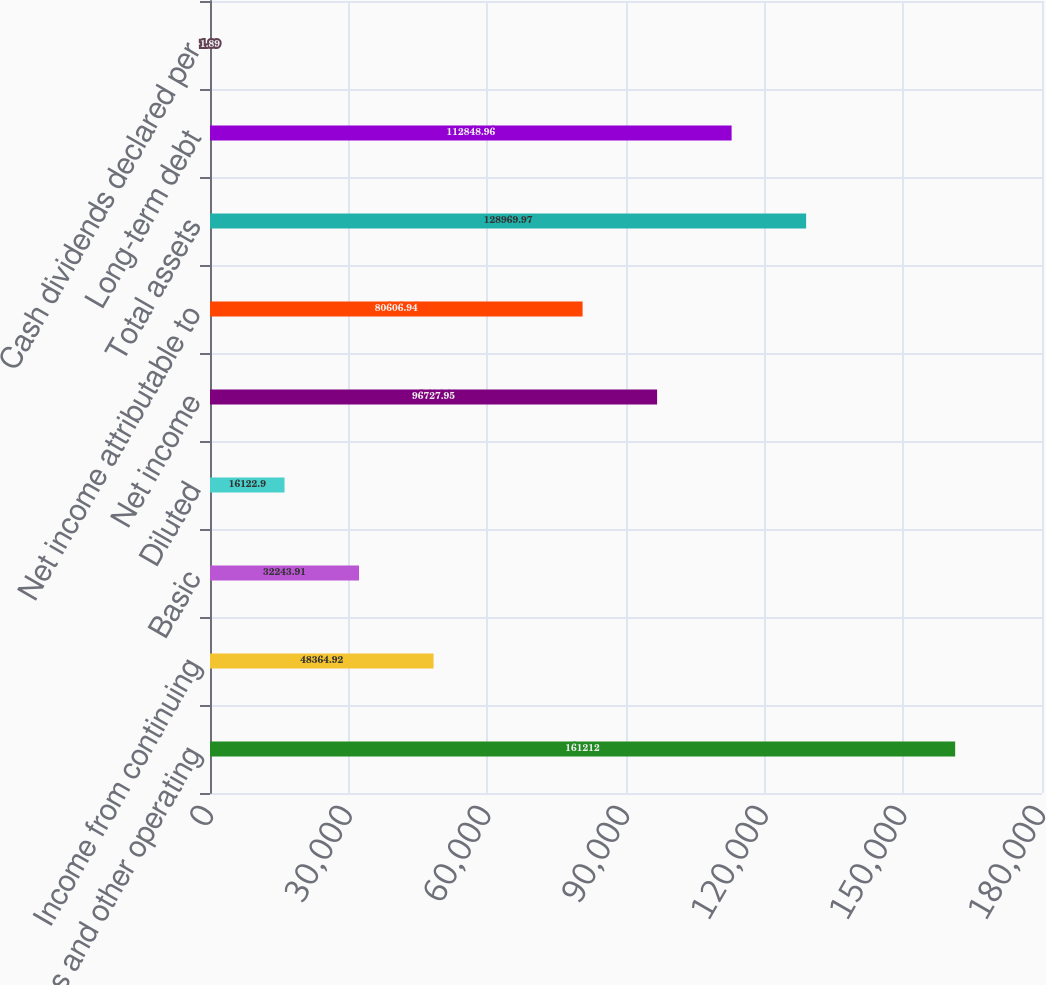Convert chart to OTSL. <chart><loc_0><loc_0><loc_500><loc_500><bar_chart><fcel>Sales and other operating<fcel>Income from continuing<fcel>Basic<fcel>Diluted<fcel>Net income<fcel>Net income attributable to<fcel>Total assets<fcel>Long-term debt<fcel>Cash dividends declared per<nl><fcel>161212<fcel>48364.9<fcel>32243.9<fcel>16122.9<fcel>96727.9<fcel>80606.9<fcel>128970<fcel>112849<fcel>1.89<nl></chart> 